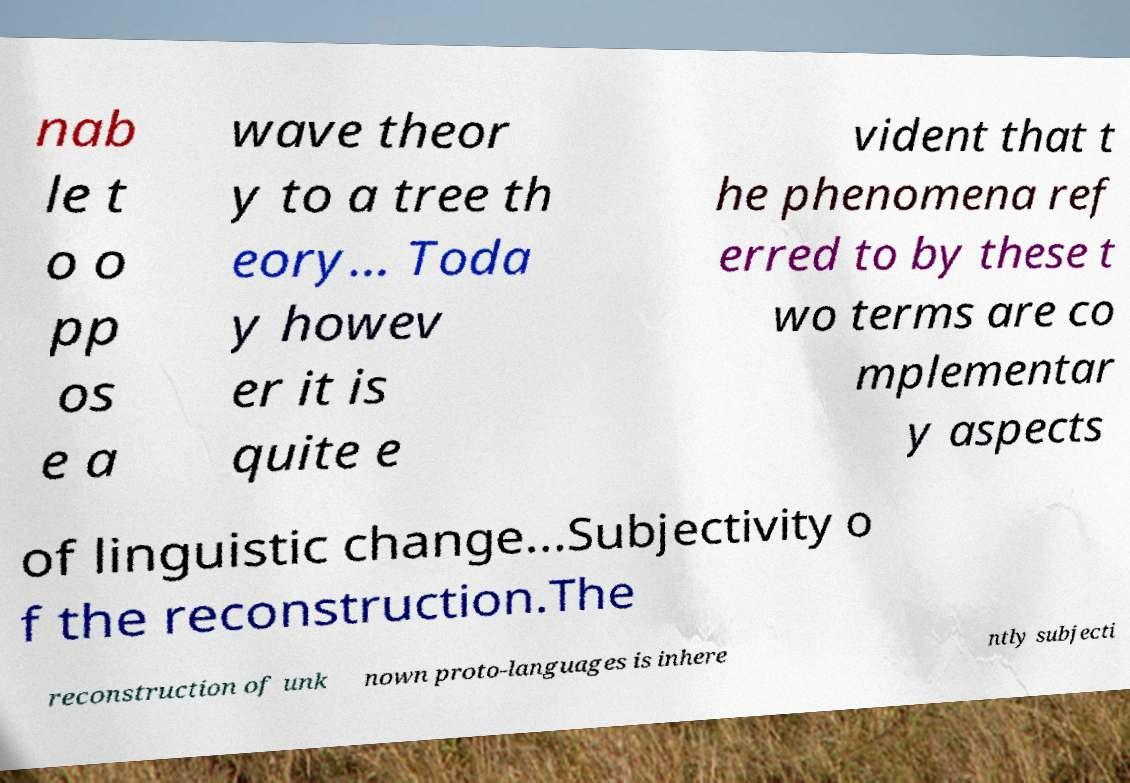Please identify and transcribe the text found in this image. nab le t o o pp os e a wave theor y to a tree th eory... Toda y howev er it is quite e vident that t he phenomena ref erred to by these t wo terms are co mplementar y aspects of linguistic change...Subjectivity o f the reconstruction.The reconstruction of unk nown proto-languages is inhere ntly subjecti 